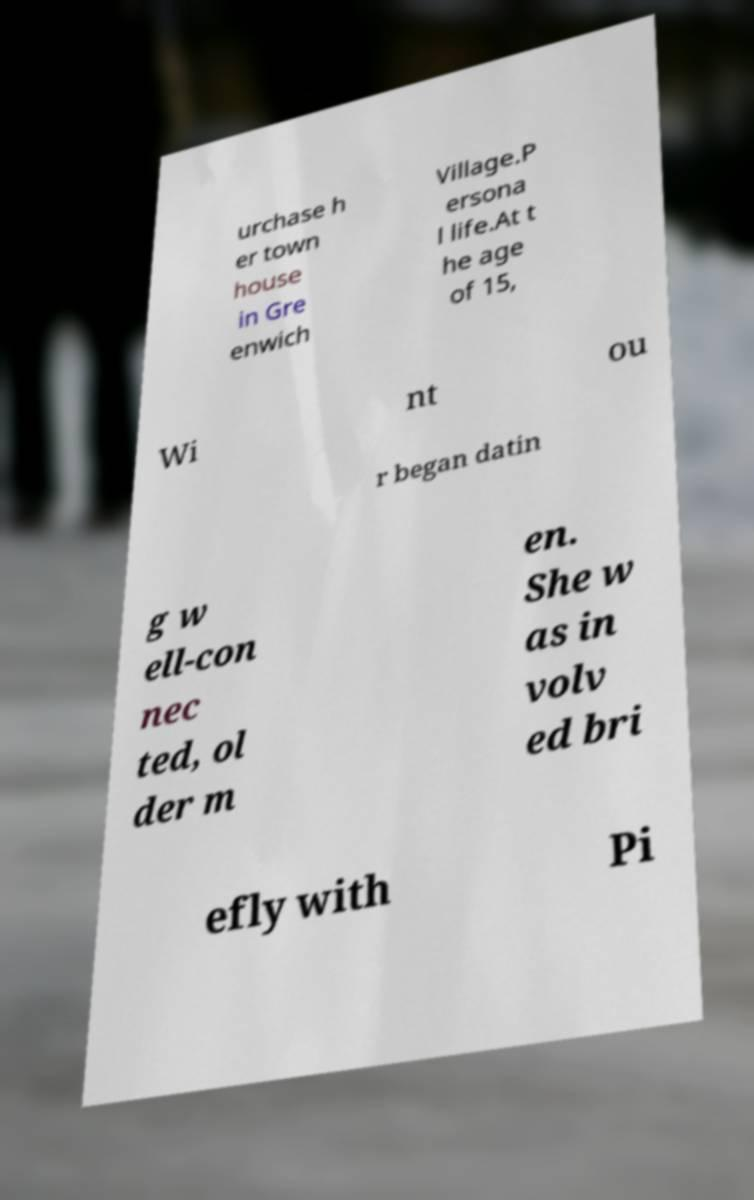Please identify and transcribe the text found in this image. urchase h er town house in Gre enwich Village.P ersona l life.At t he age of 15, Wi nt ou r began datin g w ell-con nec ted, ol der m en. She w as in volv ed bri efly with Pi 